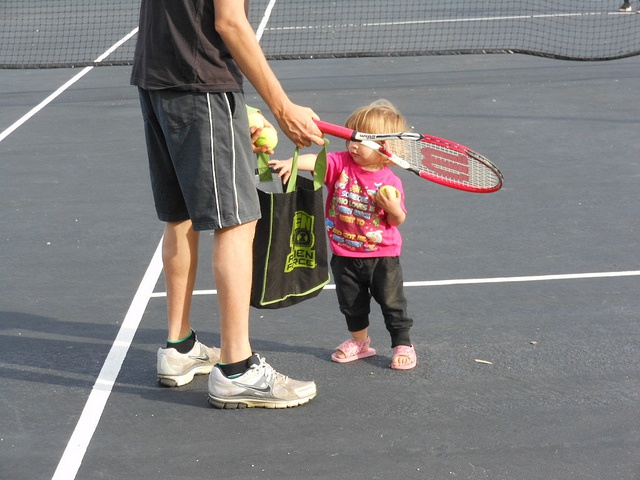Describe the objects in this image and their specific colors. I can see people in gray, black, tan, and ivory tones, people in gray, black, violet, and brown tones, handbag in gray, black, and darkgreen tones, tennis racket in gray, darkgray, lightgray, salmon, and tan tones, and sports ball in gray, khaki, lightyellow, and olive tones in this image. 